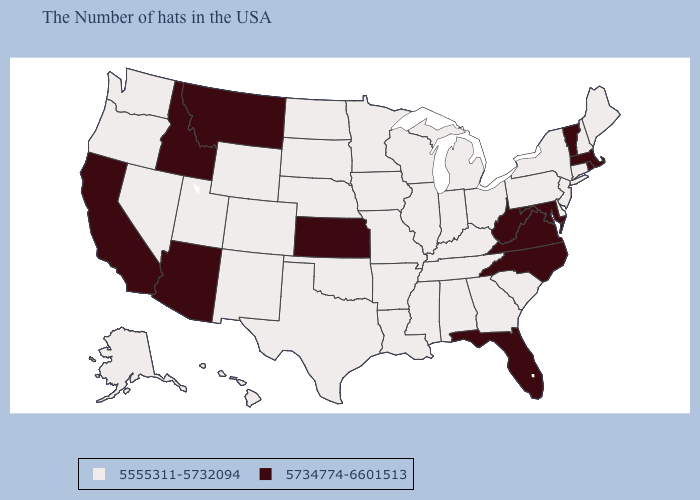What is the value of Arkansas?
Write a very short answer. 5555311-5732094. Does Indiana have the same value as New Hampshire?
Keep it brief. Yes. Among the states that border New York , does Connecticut have the highest value?
Give a very brief answer. No. Which states hav the highest value in the MidWest?
Concise answer only. Kansas. Does New Hampshire have the highest value in the Northeast?
Quick response, please. No. What is the highest value in the USA?
Concise answer only. 5734774-6601513. Name the states that have a value in the range 5734774-6601513?
Write a very short answer. Massachusetts, Rhode Island, Vermont, Maryland, Virginia, North Carolina, West Virginia, Florida, Kansas, Montana, Arizona, Idaho, California. What is the value of New Jersey?
Be succinct. 5555311-5732094. What is the highest value in states that border South Dakota?
Be succinct. 5734774-6601513. What is the value of Nebraska?
Quick response, please. 5555311-5732094. What is the value of Washington?
Quick response, please. 5555311-5732094. Among the states that border Ohio , does Indiana have the lowest value?
Answer briefly. Yes. Name the states that have a value in the range 5734774-6601513?
Concise answer only. Massachusetts, Rhode Island, Vermont, Maryland, Virginia, North Carolina, West Virginia, Florida, Kansas, Montana, Arizona, Idaho, California. Does South Dakota have the highest value in the USA?
Keep it brief. No. 